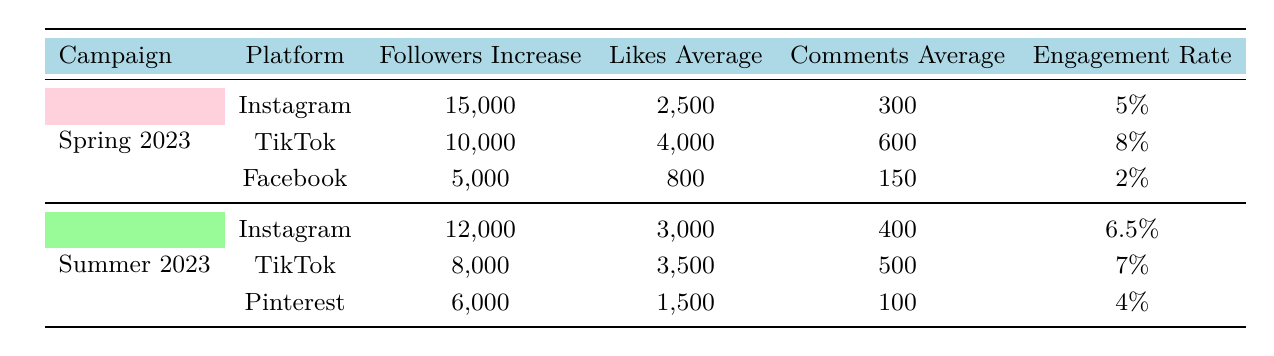What is the average engagement rate for the Spring 2023 campaign? The engagement rates for Instagram, TikTok, and Facebook under the Spring 2023 campaign are 5%, 8%, and 2%, respectively. To find the average, sum them up: 5% + 8% + 2% = 15%. Then divide by the number of platforms (3): 15% / 3 = 5%.
Answer: 5% How many followers did TikTok gain in the Summer 2023 campaign? The table shows that TikTok for the Summer 2023 campaign had a followers increase of 8,000.
Answer: 8,000 Did Facebook have a higher engagement rate than Instagram in Spring 2023? The engagement rates for Spring 2023 are 5% for Instagram and 2% for Facebook. Since 5% is greater than 2%, the statement is false.
Answer: No Which campaign had the highest total followers increase across all platforms? For Spring 2023, the total followers increase is 15,000 + 10,000 + 5,000 = 30,000. For Summer 2023, it is 12,000 + 8,000 + 6,000 = 26,000. Therefore, Spring 2023 had the highest total followers increase.
Answer: Spring 2023 What is the difference in the average likes between the two TikTok campaigns? The average likes for TikTok in Spring 2023 were 4,000, and in Summer 2023, they were 3,500. The difference is 4,000 - 3,500 = 500.
Answer: 500 Which platform had the lowest engagement rate in Summer 2023? The engagement rates for Summer 2023 are 6.5% for Instagram, 7% for TikTok, and 4% for Pinterest. Comparing these, Pinterest has the lowest engagement rate of 4%.
Answer: Pinterest How many total shares were accumulated by Instagram across both campaigns? For Spring 2023, Instagram had 1,200 shares, and for Summer 2023, it had 900 shares. The total shares earned by Instagram across both campaigns is 1,200 + 900 = 2,100.
Answer: 2,100 Was the average comments for Facebook higher than that of Pinterest in Summer 2023? In Summer 2023, Facebook had an average of 150 comments, while Pinterest had 100 comments. Since 150 is greater than 100, this statement is true.
Answer: Yes Which campaign had a higher average likes value between Instagram and TikTok? For Spring 2023, Instagram had an average of 2,500 likes and TikTok had 4,000. For Summer 2023, Instagram had 3,000 likes compared to TikTok's 3,500. The average for TikTok overall is higher at both instances.
Answer: TikTok How many comments were received on average across all platforms in Spring 2023? The average comments can be found by adding the averages: 300 (Instagram) + 600 (TikTok) + 150 (Facebook) = 1,050. Then divide by the number of platforms (3): 1,050 / 3 = 350.
Answer: 350 